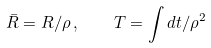<formula> <loc_0><loc_0><loc_500><loc_500>\bar { R } = R / \rho \, , \quad T = \int { d t } / \rho ^ { 2 }</formula> 